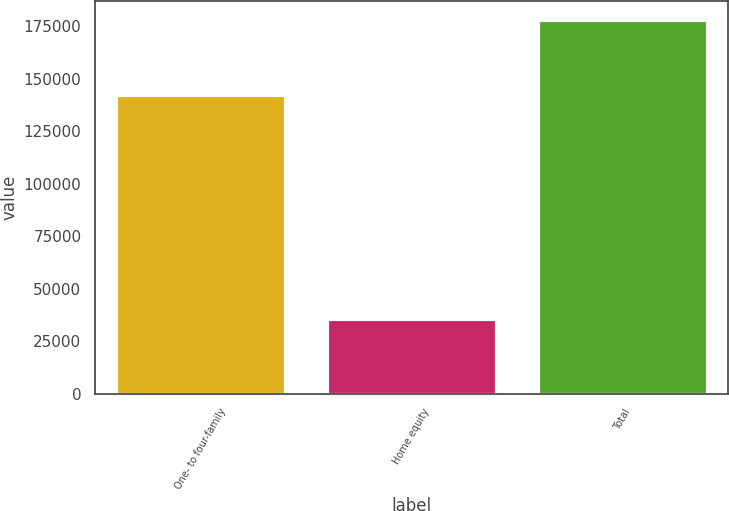<chart> <loc_0><loc_0><loc_500><loc_500><bar_chart><fcel>One- to four-family<fcel>Home equity<fcel>Total<nl><fcel>142373<fcel>35750<fcel>178123<nl></chart> 